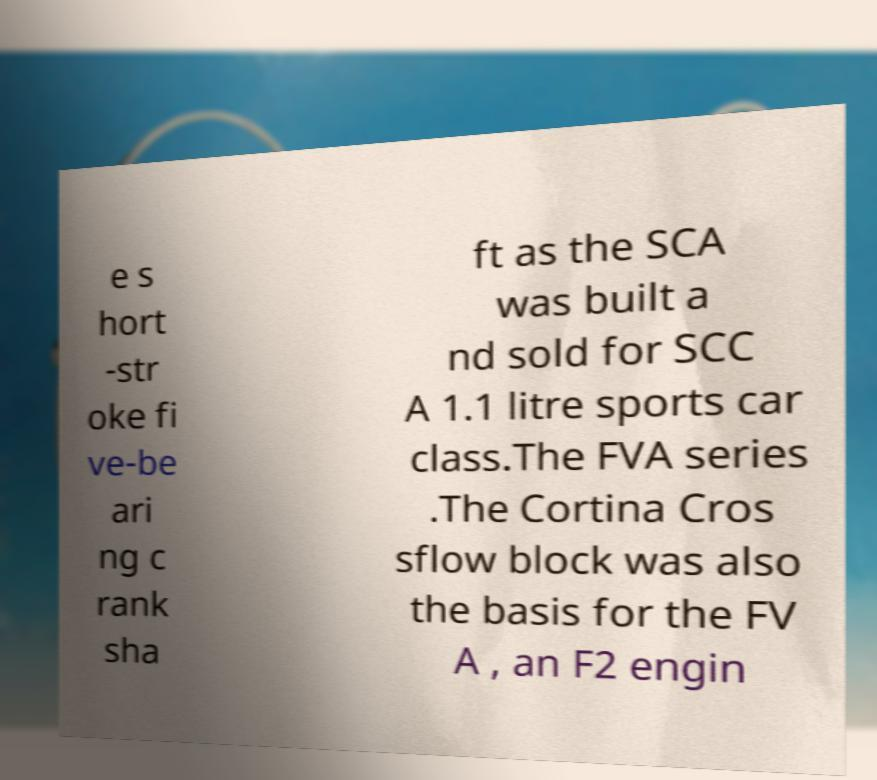Could you assist in decoding the text presented in this image and type it out clearly? e s hort -str oke fi ve-be ari ng c rank sha ft as the SCA was built a nd sold for SCC A 1.1 litre sports car class.The FVA series .The Cortina Cros sflow block was also the basis for the FV A , an F2 engin 